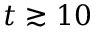Convert formula to latex. <formula><loc_0><loc_0><loc_500><loc_500>t \gtrsim 1 0</formula> 